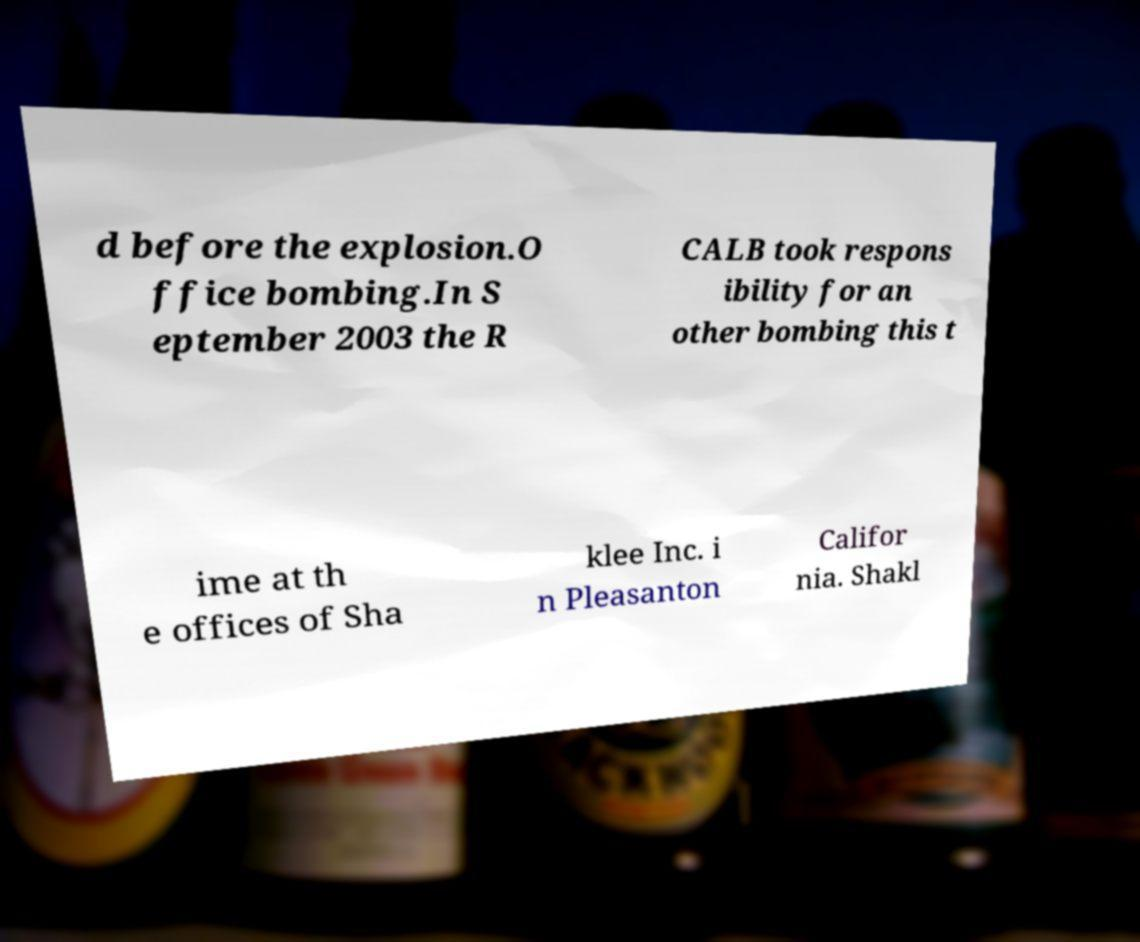What messages or text are displayed in this image? I need them in a readable, typed format. d before the explosion.O ffice bombing.In S eptember 2003 the R CALB took respons ibility for an other bombing this t ime at th e offices of Sha klee Inc. i n Pleasanton Califor nia. Shakl 